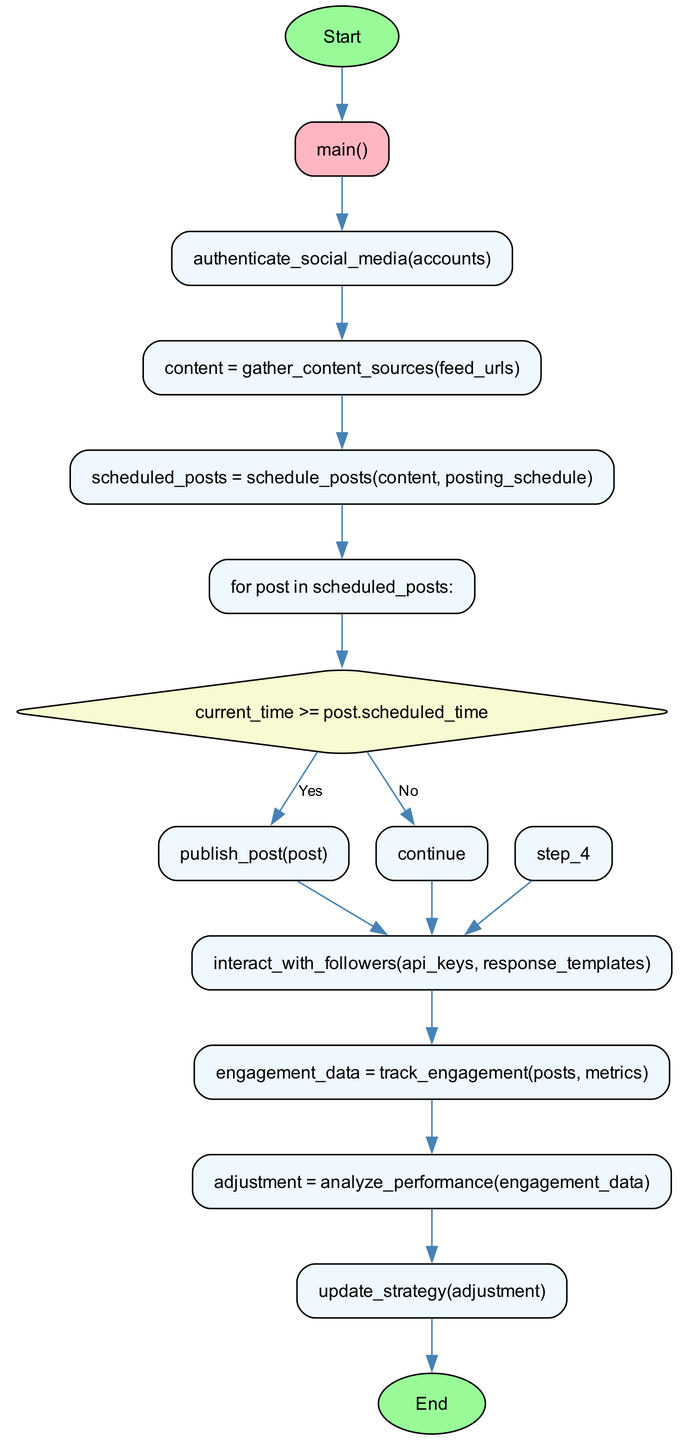What's the first step in the flowchart? The first step in the flowchart is 'authenticate_social_media(accounts)', which is directly connected to the 'main()' function.
Answer: authenticate_social_media(accounts) How many steps are in the flowchart? The flowchart contains a total of 8 steps, including the conditional and branching logic.
Answer: 8 What happens if the current time is not greater than or equal to the post's scheduled time? If the current time is not greater than or equal to the post's scheduled time, the flowchart indicates to 'continue' rather than proceeding to publish the post.
Answer: continue What is the last action taken in the process? The last action taken in the diagram is 'update_strategy(adjustment)', which has an edge leading to the final node labeled 'End'.
Answer: update_strategy(adjustment) Which function gathers content sources? The function that gathers content sources is 'gather_content_sources(feed_urls)', indicated as one of the steps following the authentication step in the flow of the diagram.
Answer: gather_content_sources(feed_urls) What decision is made after scheduling posts? The decision made after scheduling posts is to check if 'current_time >= post.scheduled_time', leading to either publishing the post or continuing.
Answer: current_time >= post.scheduled_time Which step comes immediately after tracking engagement? The step that comes immediately after tracking engagement, which involves 'engagement_data = track_engagement(posts, metrics)', is 'adjustment = analyze_performance(engagement_data)'.
Answer: adjustment = analyze_performance(engagement_data) How does the flowchart handle interactions with followers? The flowchart handles interactions with followers through the step 'interact_with_followers(api_keys, response_templates)', which is appropriately placed after scheduling posts and checking engagement.
Answer: interact_with_followers(api_keys, response_templates) 